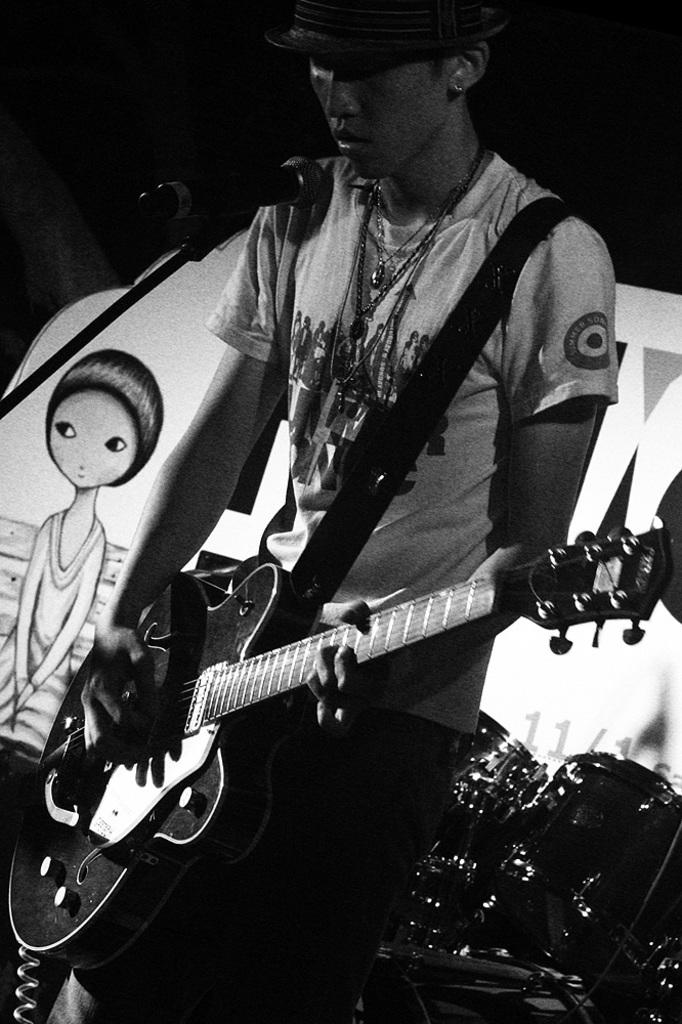Who is the main subject in the image? There is a man in the image. Where is the man located in the image? The man is standing on a stage. What is the man holding in the image? The man is holding a guitar. What is the man positioned in front of in the image? The man is in front of a microphone. What type of juice can be seen in the man's hand in the image? There is no juice present in the image; the man is holding a guitar. 